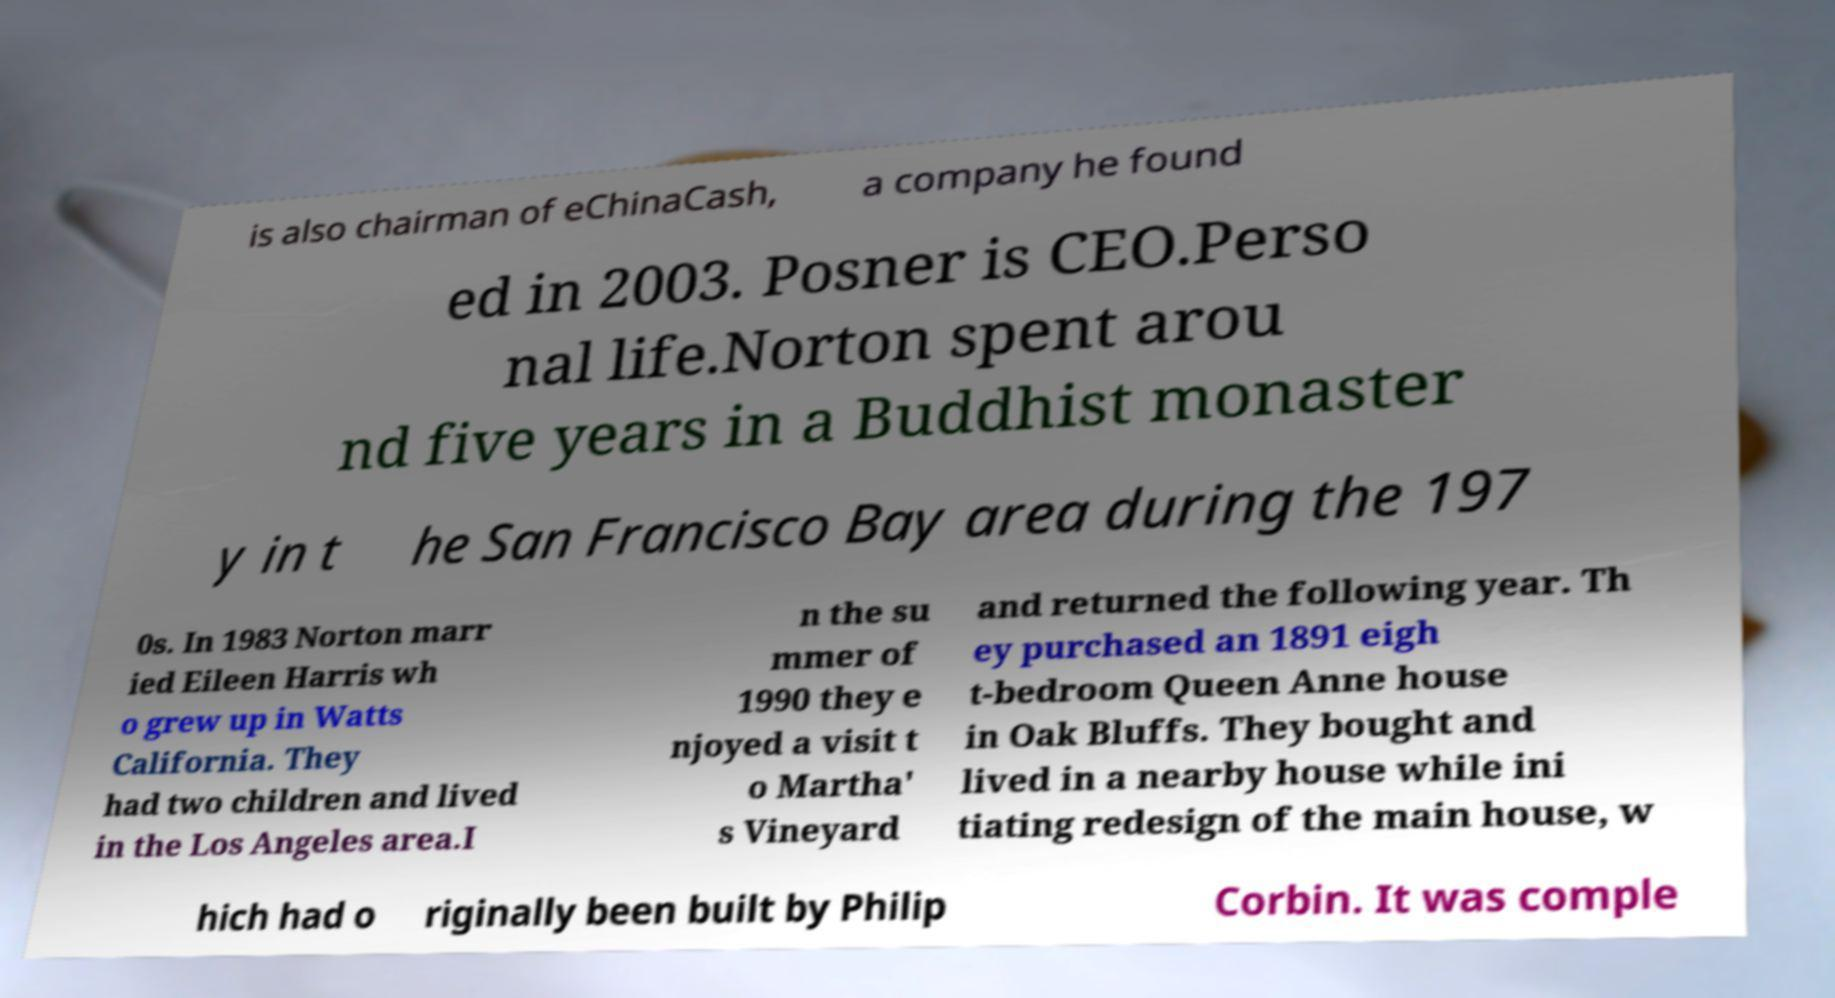What messages or text are displayed in this image? I need them in a readable, typed format. is also chairman of eChinaCash, a company he found ed in 2003. Posner is CEO.Perso nal life.Norton spent arou nd five years in a Buddhist monaster y in t he San Francisco Bay area during the 197 0s. In 1983 Norton marr ied Eileen Harris wh o grew up in Watts California. They had two children and lived in the Los Angeles area.I n the su mmer of 1990 they e njoyed a visit t o Martha' s Vineyard and returned the following year. Th ey purchased an 1891 eigh t-bedroom Queen Anne house in Oak Bluffs. They bought and lived in a nearby house while ini tiating redesign of the main house, w hich had o riginally been built by Philip Corbin. It was comple 